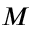Convert formula to latex. <formula><loc_0><loc_0><loc_500><loc_500>M</formula> 